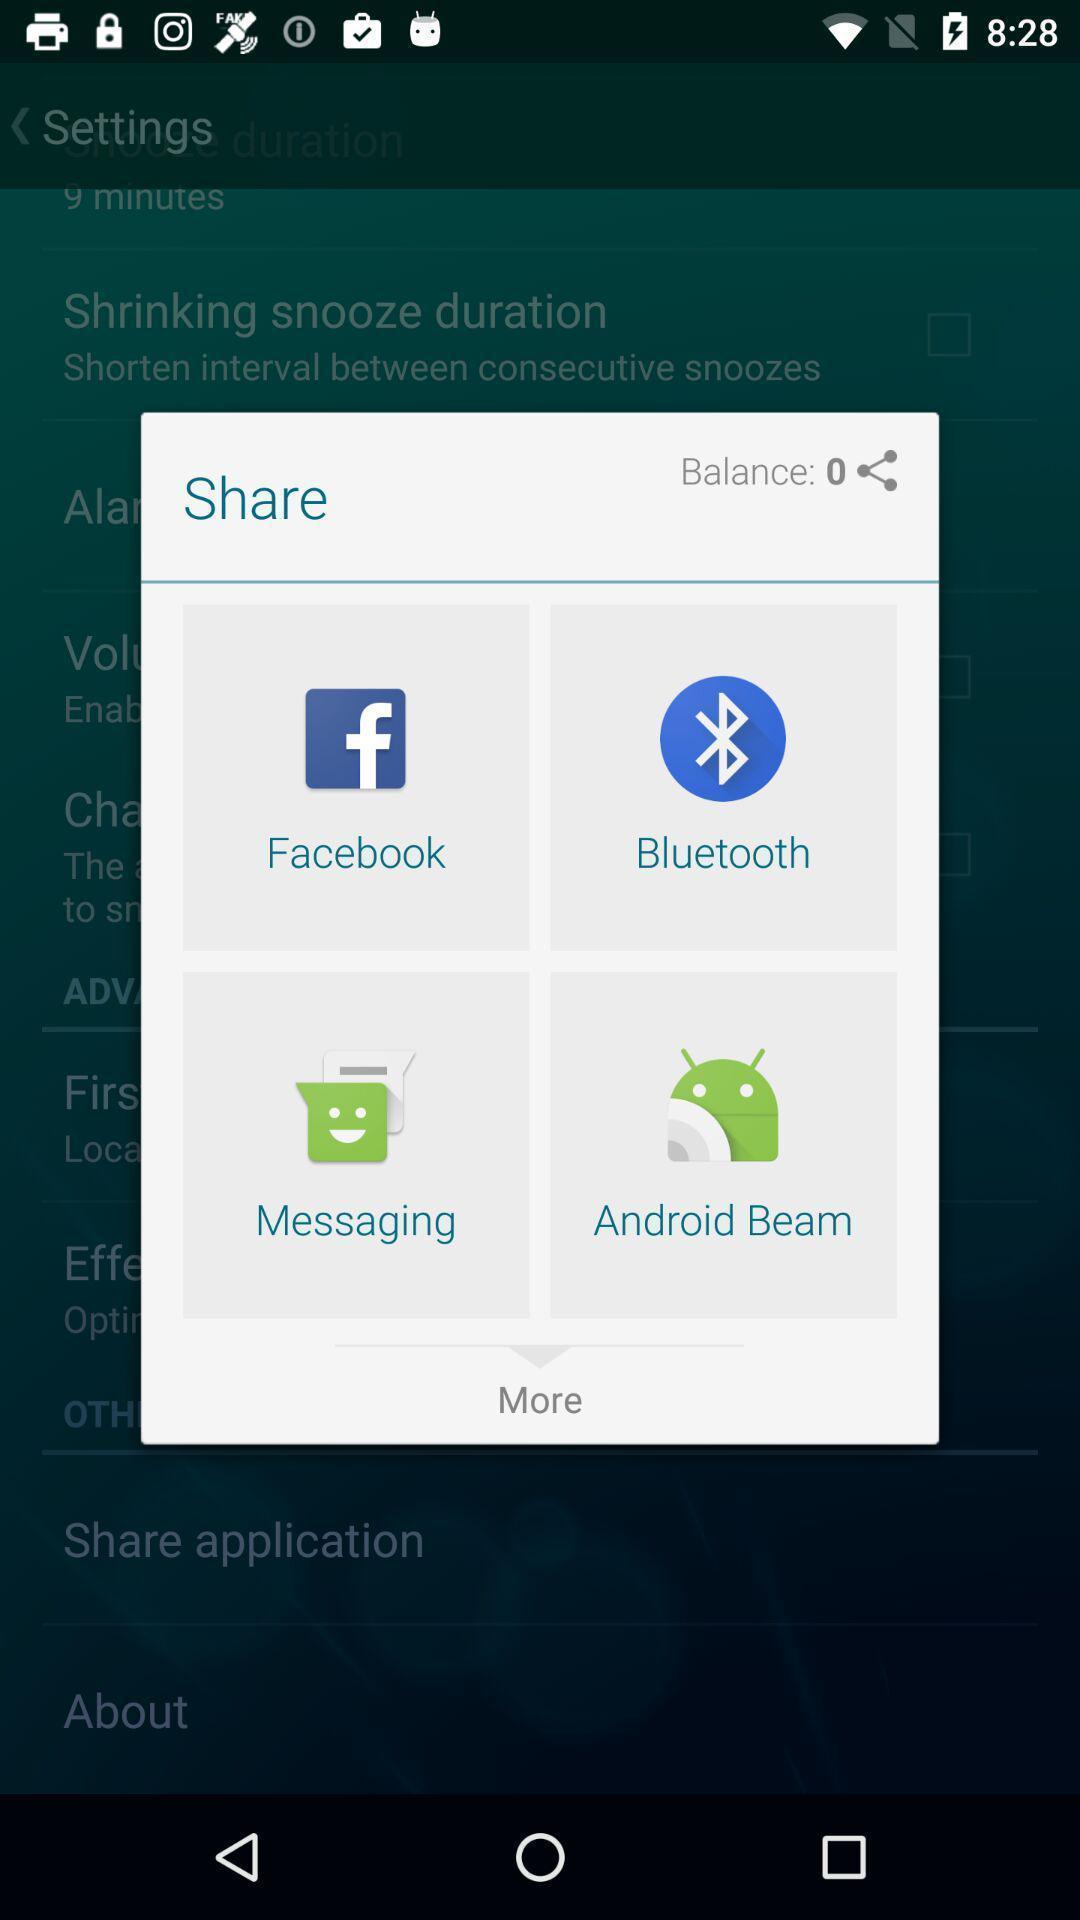Describe the visual elements of this screenshot. Pop-up showing to share through different apps. 